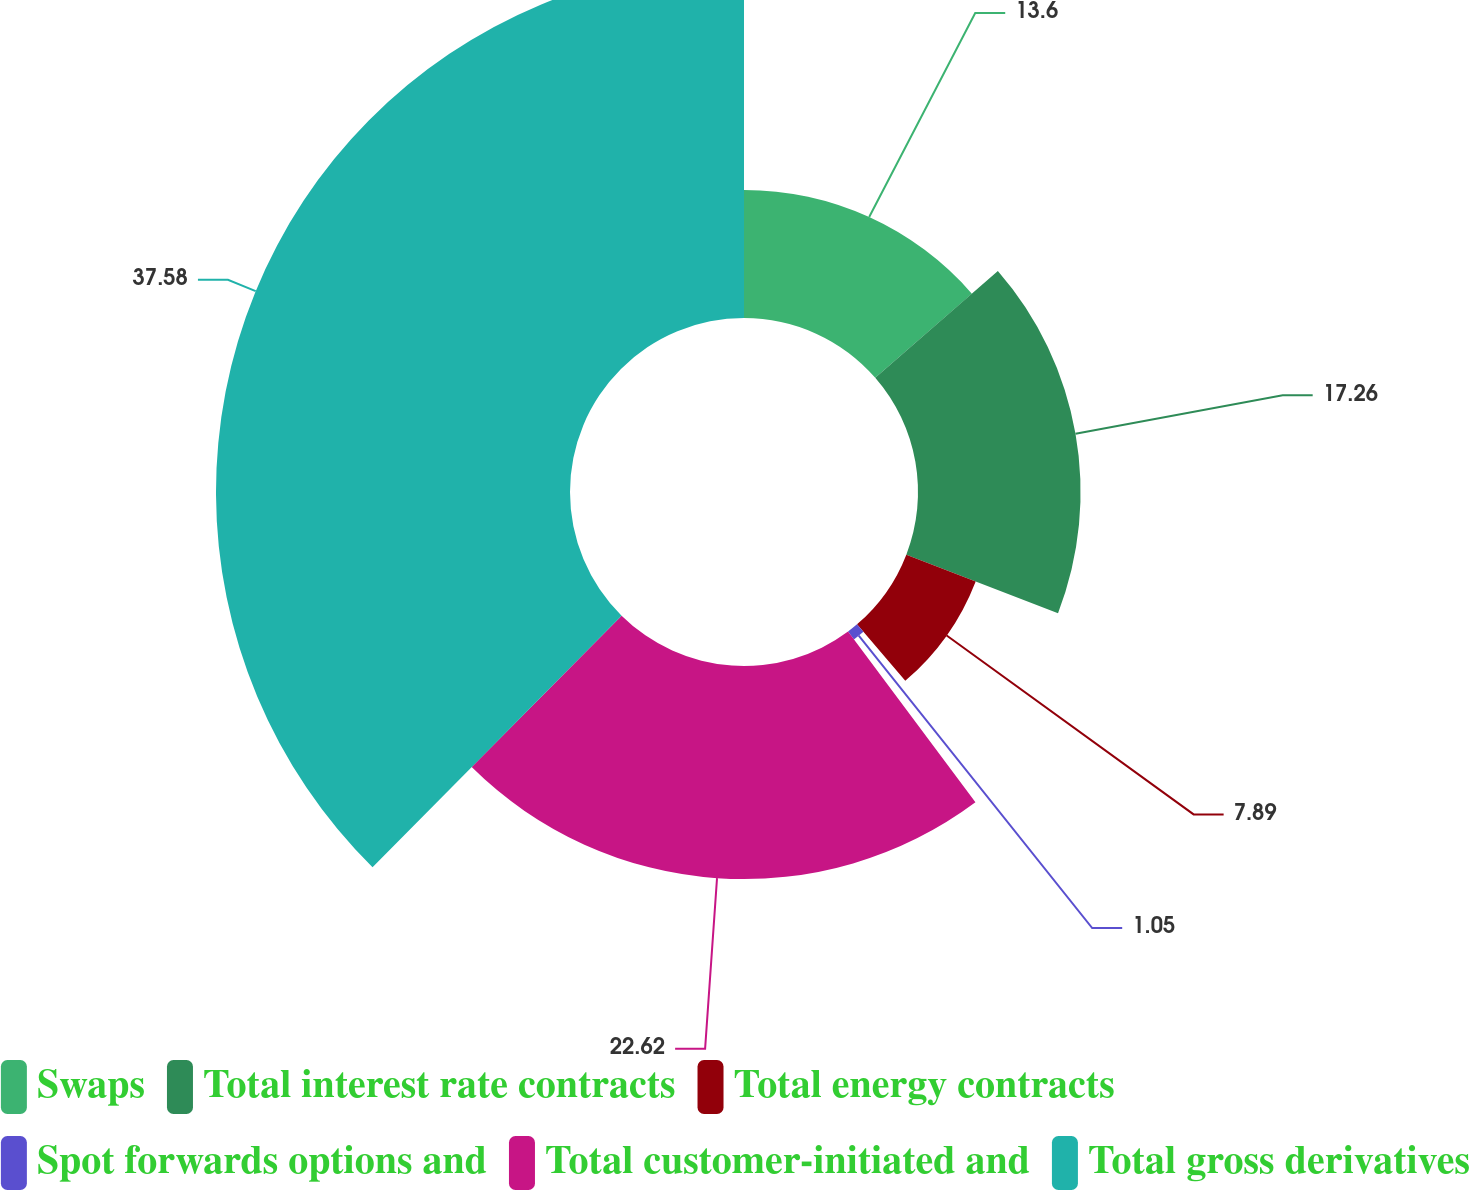Convert chart. <chart><loc_0><loc_0><loc_500><loc_500><pie_chart><fcel>Swaps<fcel>Total interest rate contracts<fcel>Total energy contracts<fcel>Spot forwards options and<fcel>Total customer-initiated and<fcel>Total gross derivatives<nl><fcel>13.6%<fcel>17.26%<fcel>7.89%<fcel>1.05%<fcel>22.62%<fcel>37.58%<nl></chart> 